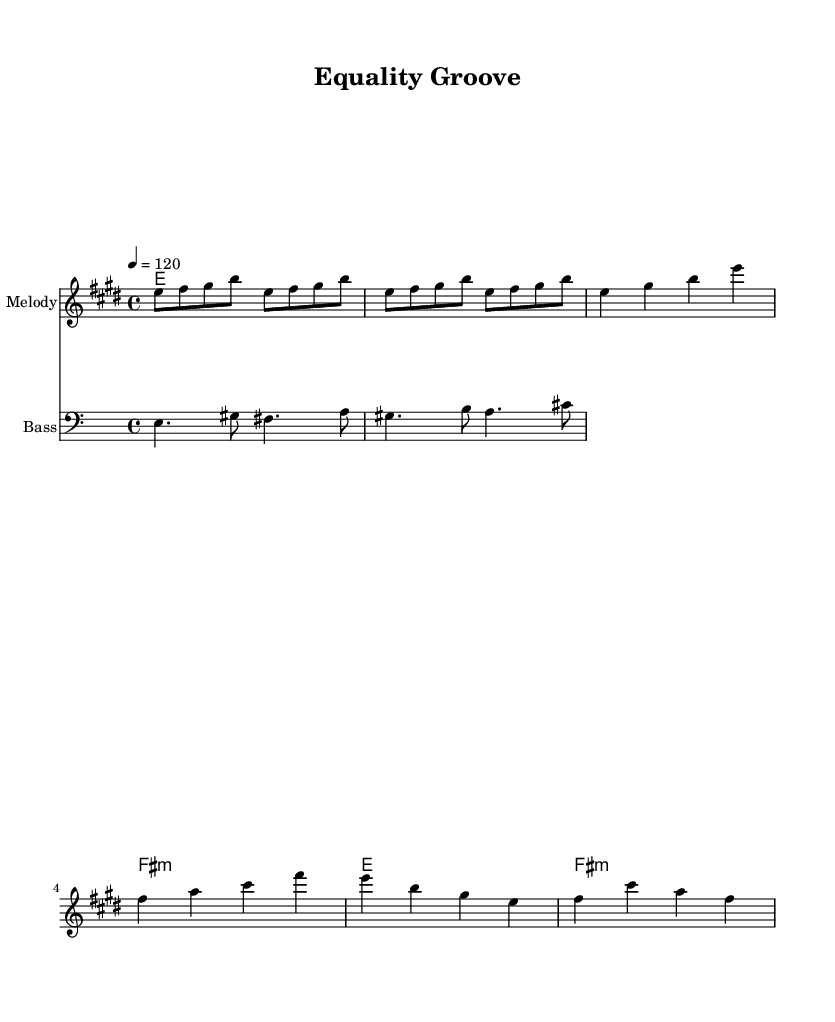What is the key signature of this music? The key signature is indicated at the beginning of the score, which shows the presence of four sharps, corresponding to E major.
Answer: E major What is the time signature of the music? The time signature is found at the beginning of the score, showing a 4 over 4, indicating common time.
Answer: 4/4 What is the tempo marking for this piece? The tempo marking is given in beats per minute at the start, which shows the tempo is set at 120 beats per minute.
Answer: 120 How many measures are in the chorus section? The chorus section consists of four measures, as seen from the repeated patterns before and after the written bars.
Answer: 4 What chord follows the E chord in the verse? In the verse, the E chord is followed immediately by the F# minor chord, as seen in the chord changes provided beneath the melody.
Answer: F# minor What is the root note of the bass line's first measure? The first measure of the bass line starts on E, which is clearly indicated as the first note in the relative bass clef part.
Answer: E What style does this piece represent based on its rhythmic and harmonic characteristics? The upbeat and syncopated rhythm, along with the use of dominant 7th chords and a groovy bassline, is indicative of funk music.
Answer: Funk 